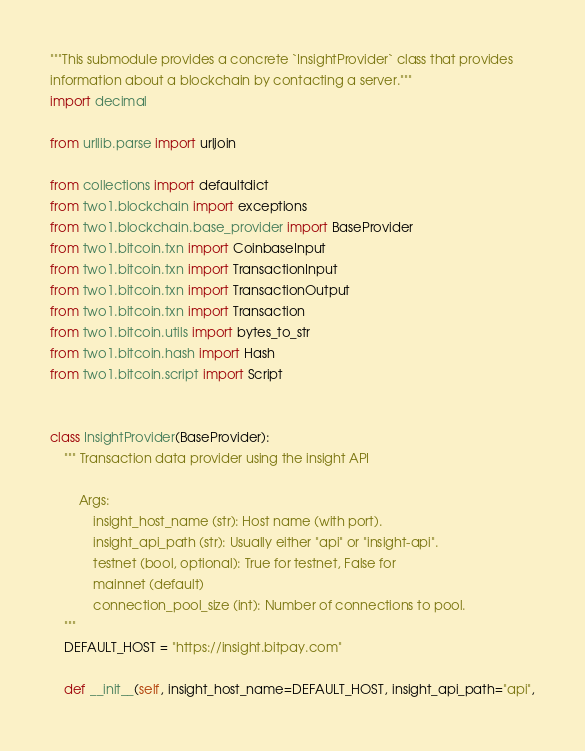<code> <loc_0><loc_0><loc_500><loc_500><_Python_>"""This submodule provides a concrete `InsightProvider` class that provides
information about a blockchain by contacting a server."""
import decimal

from urllib.parse import urljoin

from collections import defaultdict
from two1.blockchain import exceptions
from two1.blockchain.base_provider import BaseProvider
from two1.bitcoin.txn import CoinbaseInput
from two1.bitcoin.txn import TransactionInput
from two1.bitcoin.txn import TransactionOutput
from two1.bitcoin.txn import Transaction
from two1.bitcoin.utils import bytes_to_str
from two1.bitcoin.hash import Hash
from two1.bitcoin.script import Script


class InsightProvider(BaseProvider):
    """ Transaction data provider using the insight API

        Args:
            insight_host_name (str): Host name (with port).
            insight_api_path (str): Usually either "api" or "insight-api".
            testnet (bool, optional): True for testnet, False for
            mainnet (default)
            connection_pool_size (int): Number of connections to pool.
    """
    DEFAULT_HOST = "https://insight.bitpay.com"

    def __init__(self, insight_host_name=DEFAULT_HOST, insight_api_path="api",</code> 